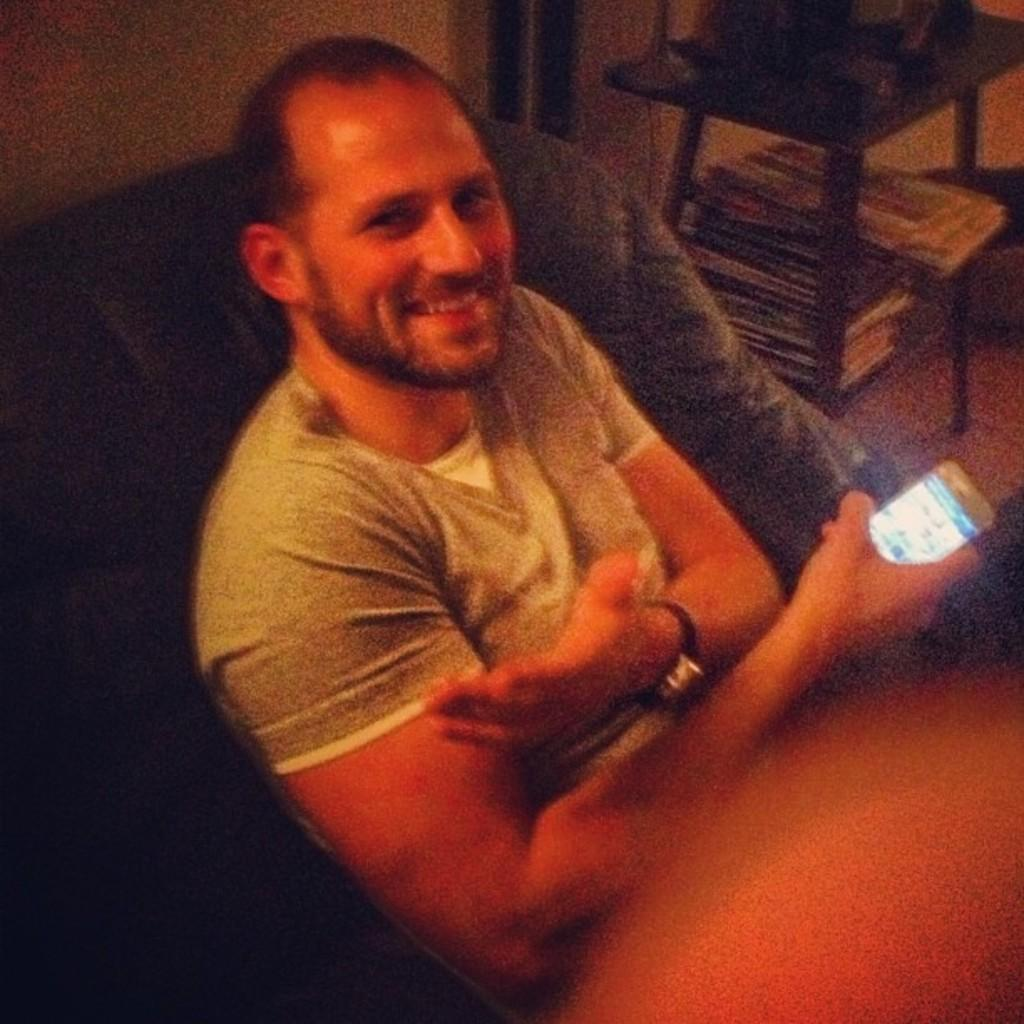What is the main subject of the image? There is a man in the image. What is the man doing in the image? The man is sitting. What object is the man holding in the image? The man is holding a mobile. What can be seen on the shelf in the image? There are books on a shelf. Where is the shelf located in relation to the stool? The shelf is under a stool. What is visible behind the man in the image? There is a wall behind the man. What type of curtain is hanging from the ceiling in the image? There is no curtain present in the image. What operation is the man performing on the mobile in the image? The man is not performing any operation on the mobile in the image; he is simply holding it. 